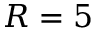Convert formula to latex. <formula><loc_0><loc_0><loc_500><loc_500>R = 5</formula> 